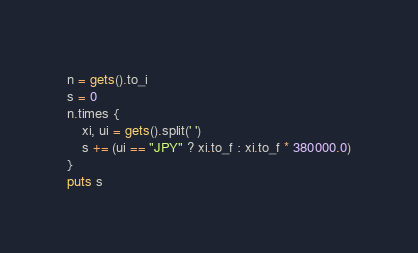Convert code to text. <code><loc_0><loc_0><loc_500><loc_500><_Ruby_>n = gets().to_i
s = 0
n.times {
	xi, ui = gets().split(' ')
	s += (ui == "JPY" ? xi.to_f : xi.to_f * 380000.0)
}
puts s
</code> 